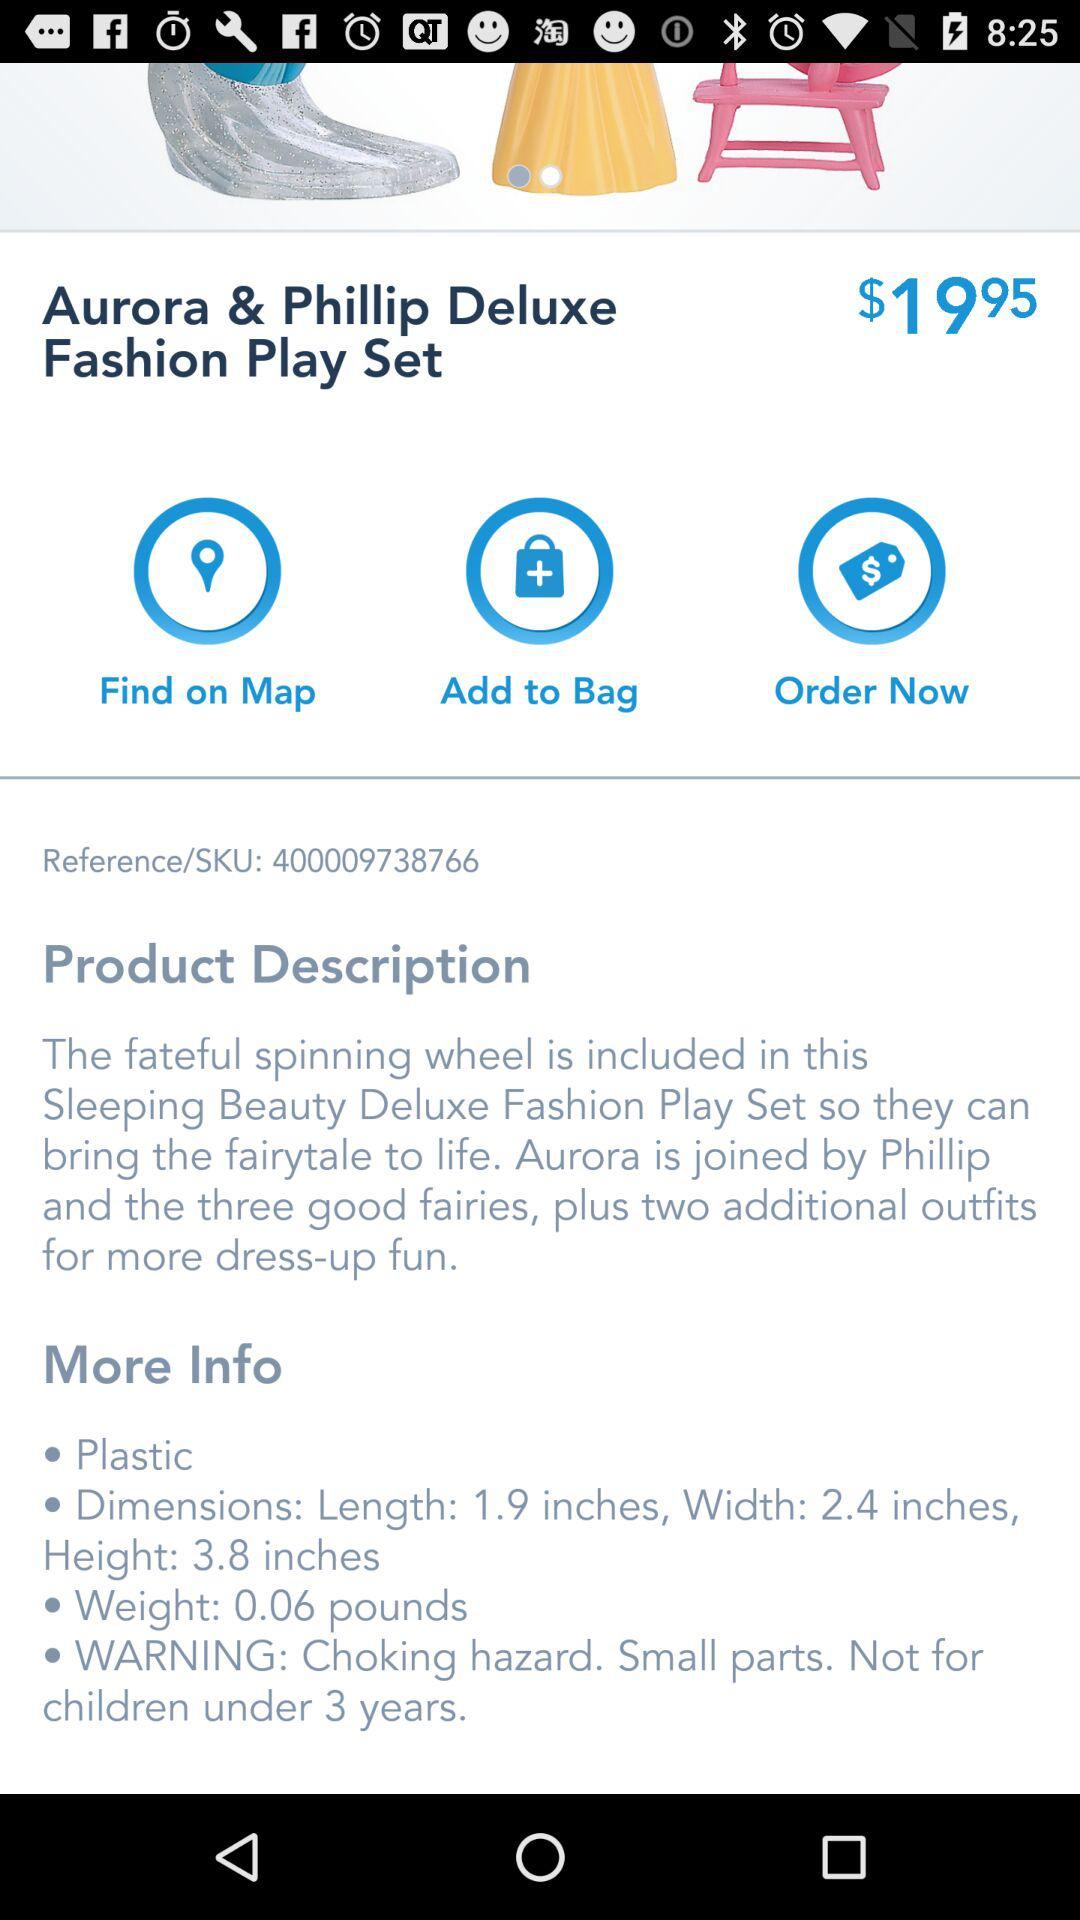What is the height of the selected play set? The height is 3.8 inches. 